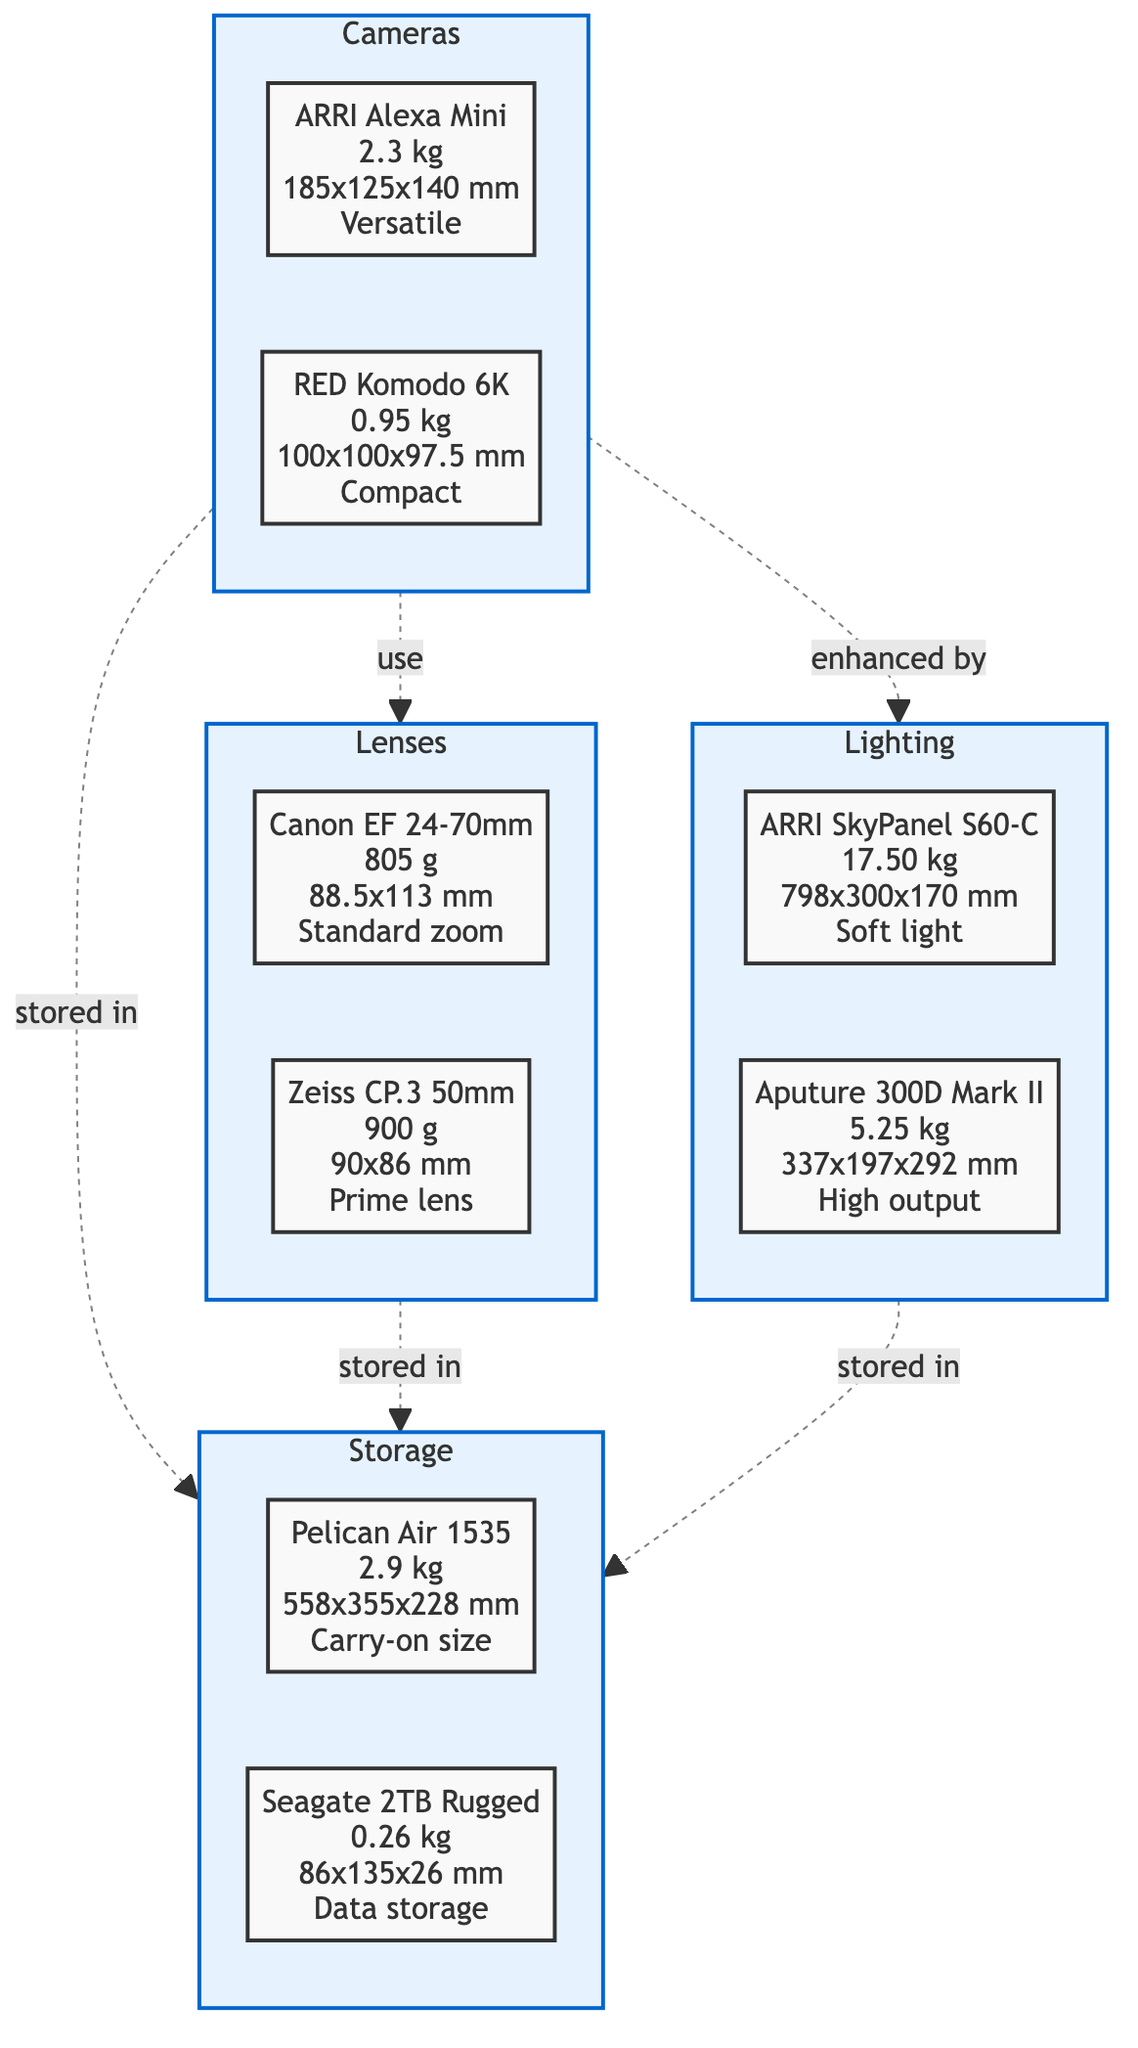What is the weight of the ARRI Alexa Mini? The ARRI Alexa Mini is specified with a weight of 2.3 kg, which can be directly observed in the diagram next to its label.
Answer: 2.3 kg How many lenses are listed in the diagram? The diagram shows two lenses listed: Canon EF 24-70mm and Zeiss CP.3 50mm. Counting these provides the total number of lenses.
Answer: 2 Which lighting setup has the highest weight? The diagram indicates that the ARRI SkyPanel S60-C weighs 17.50 kg, the highest among all lighting setups listed.
Answer: ARRI SkyPanel S60-C What is the size dimension of the Seagate 2TB Rugged? Looking at the diagram, the size of the Seagate 2TB Rugged is indicated as 86x135x26 mm. This is clearly labeled under its entry in the storage section.
Answer: 86x135x26 mm Which equipment category is stored in the Pelican Air 1535? The diagram shows arrows indicating that Cameras, Lenses, and Lighting are all stored within Storage. Therefore, the Pelican Air 1535 is storing these equipment categories.
Answer: Cameras, Lenses, and Lighting How do the Cameras connect to the Lighting in this diagram? In the diagram, the connection between Cameras and Lighting is indicated by a dashed line labeled “enhanced by”, showing that the Lighting setup enhances the Cameras.
Answer: enhanced by What is the use-case for the Canon EF 24-70mm lens? The use-case for the Canon EF 24-70mm lens is labeled as "Standard zoom" in the provided diagram. This description directly indicates its intended purpose.
Answer: Standard zoom Which piece of equipment is the lightest? The lightest piece of equipment is the Seagate 2TB Rugged, weighing only 0.26 kg, as can be seen in the storage section of the diagram.
Answer: Seagate 2TB Rugged How many connection styles are represented in the diagram? The diagram depicts three distinct connection styles, indicated by arrows between Cameras, Lenses, and Lighting to Storage, which can be counted visually.
Answer: 3 